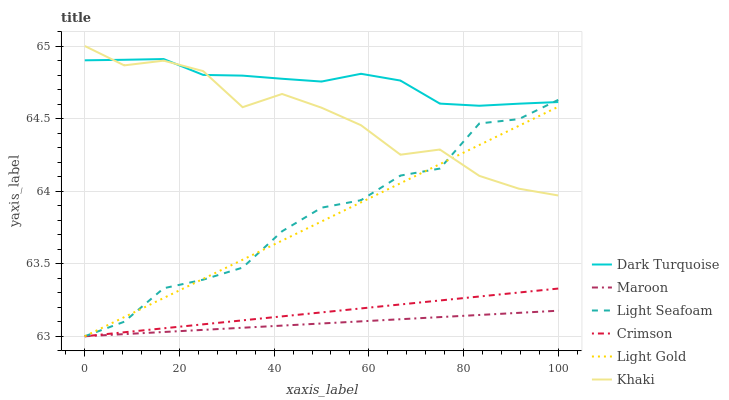Does Maroon have the minimum area under the curve?
Answer yes or no. Yes. Does Dark Turquoise have the maximum area under the curve?
Answer yes or no. Yes. Does Dark Turquoise have the minimum area under the curve?
Answer yes or no. No. Does Maroon have the maximum area under the curve?
Answer yes or no. No. Is Crimson the smoothest?
Answer yes or no. Yes. Is Khaki the roughest?
Answer yes or no. Yes. Is Dark Turquoise the smoothest?
Answer yes or no. No. Is Dark Turquoise the roughest?
Answer yes or no. No. Does Maroon have the lowest value?
Answer yes or no. Yes. Does Dark Turquoise have the lowest value?
Answer yes or no. No. Does Khaki have the highest value?
Answer yes or no. Yes. Does Dark Turquoise have the highest value?
Answer yes or no. No. Is Crimson less than Khaki?
Answer yes or no. Yes. Is Khaki greater than Maroon?
Answer yes or no. Yes. Does Crimson intersect Light Seafoam?
Answer yes or no. Yes. Is Crimson less than Light Seafoam?
Answer yes or no. No. Is Crimson greater than Light Seafoam?
Answer yes or no. No. Does Crimson intersect Khaki?
Answer yes or no. No. 